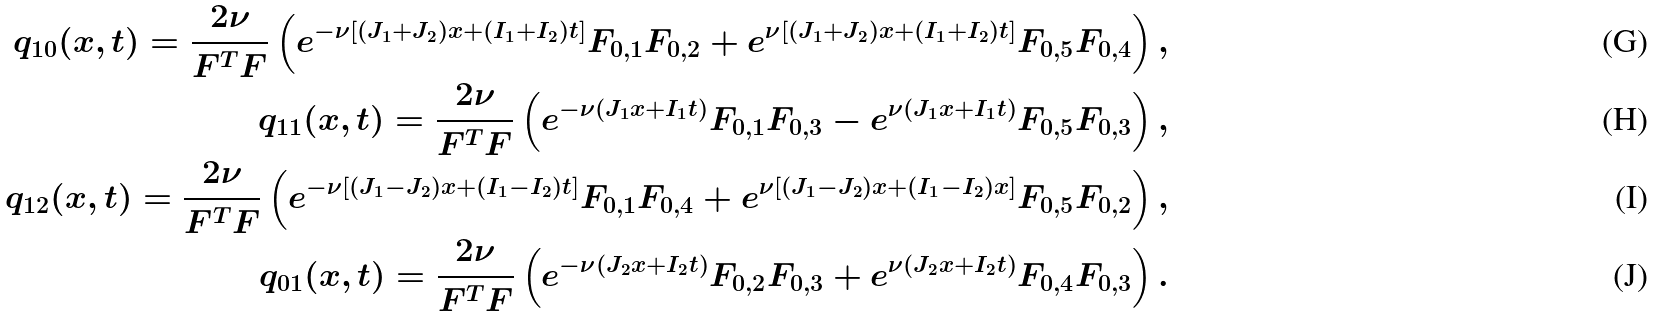<formula> <loc_0><loc_0><loc_500><loc_500>q _ { 1 0 } ( x , t ) = \frac { 2 \nu } { F ^ { T } F } \left ( e ^ { - \nu [ ( J _ { 1 } + J _ { 2 } ) x + ( I _ { 1 } + I _ { 2 } ) t ] } F _ { 0 , 1 } F _ { 0 , 2 } + e ^ { \nu [ ( J _ { 1 } + J _ { 2 } ) x + ( I _ { 1 } + I _ { 2 } ) t ] } F _ { 0 , 5 } F _ { 0 , 4 } \right ) , \\ q _ { 1 1 } ( x , t ) = \frac { 2 \nu } { F ^ { T } F } \left ( e ^ { - \nu ( J _ { 1 } x + I _ { 1 } t ) } F _ { 0 , 1 } F _ { 0 , 3 } - e ^ { \nu ( J _ { 1 } x + I _ { 1 } t ) } F _ { 0 , 5 } F _ { 0 , 3 } \right ) , \\ q _ { 1 2 } ( x , t ) = \frac { 2 \nu } { F ^ { T } F } \left ( e ^ { - \nu [ ( J _ { 1 } - J _ { 2 } ) x + ( I _ { 1 } - I _ { 2 } ) t ] } F _ { 0 , 1 } F _ { 0 , 4 } + e ^ { \nu [ ( J _ { 1 } - J _ { 2 } ) x + ( I _ { 1 } - I _ { 2 } ) x ] } F _ { 0 , 5 } F _ { 0 , 2 } \right ) , \\ q _ { 0 1 } ( x , t ) = \frac { 2 \nu } { F ^ { T } F } \left ( e ^ { - \nu ( J _ { 2 } x + I _ { 2 } t ) } F _ { 0 , 2 } F _ { 0 , 3 } + e ^ { \nu ( J _ { 2 } x + I _ { 2 } t ) } F _ { 0 , 4 } F _ { 0 , 3 } \right ) .</formula> 